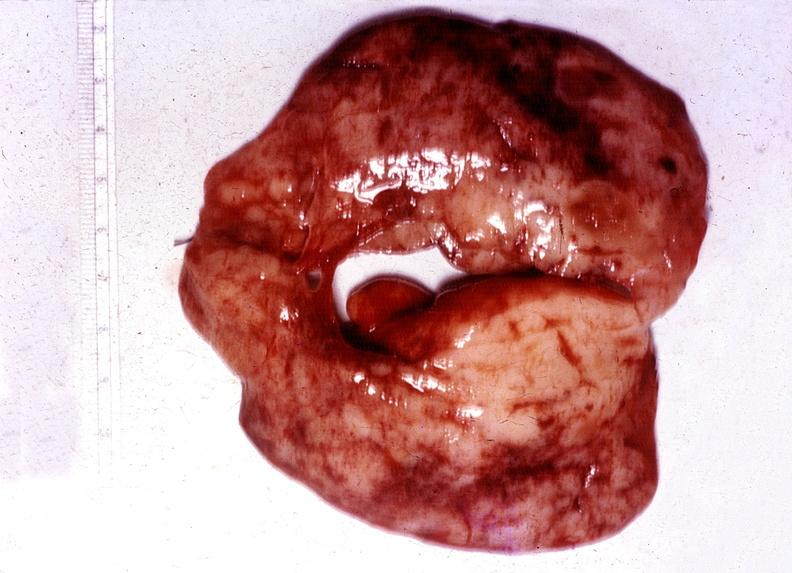does this image show thyroid, hashimotos?
Answer the question using a single word or phrase. Yes 